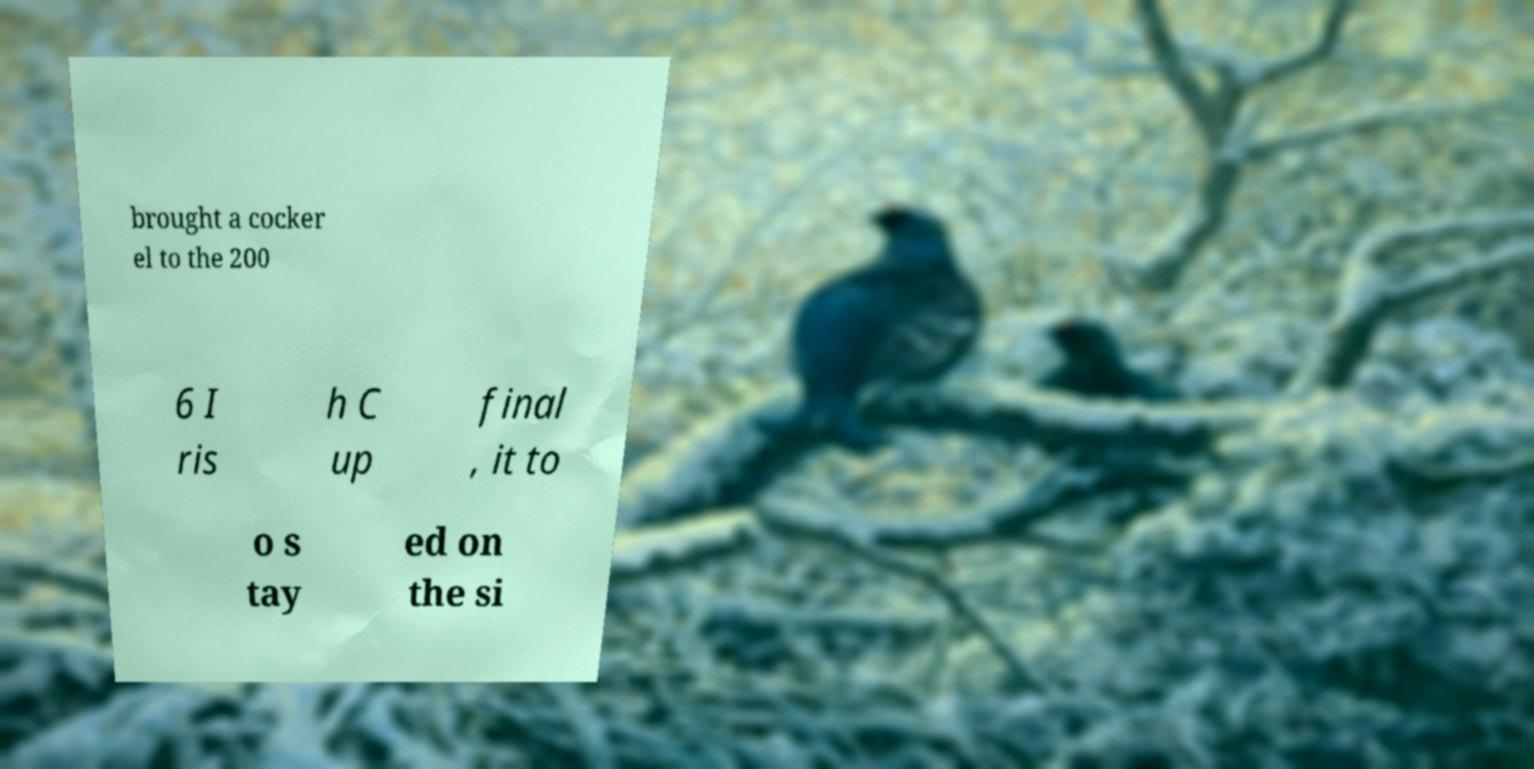Can you accurately transcribe the text from the provided image for me? brought a cocker el to the 200 6 I ris h C up final , it to o s tay ed on the si 